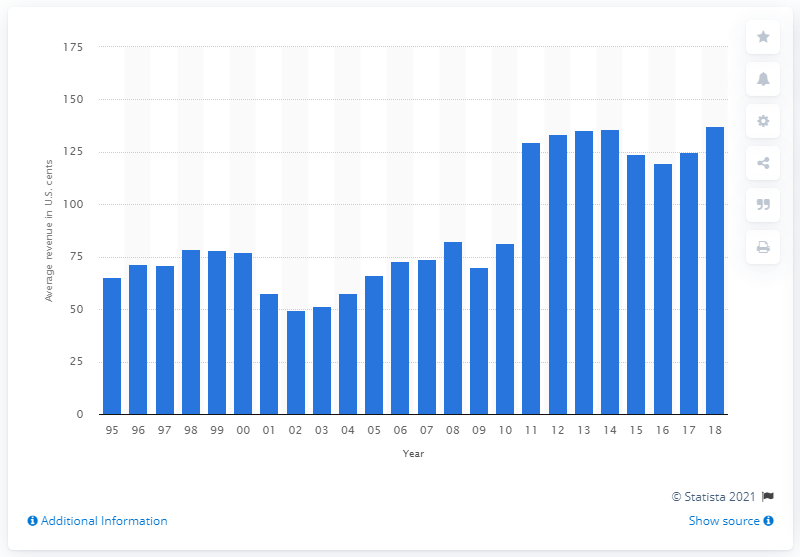Outline some significant characteristics in this image. In 2018, the average revenue per ton-mile for domestic air freight in the U.S. was $137.49 in dollar cents. 